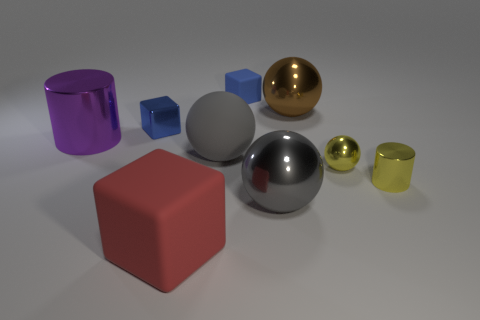How big is the object that is both in front of the blue shiny cube and on the left side of the big red matte object?
Ensure brevity in your answer.  Large. Is there a small object that has the same color as the small sphere?
Keep it short and to the point. Yes. There is a cylinder on the left side of the small blue cube on the left side of the red cube; what is its color?
Your answer should be very brief. Purple. Are there fewer tiny yellow cylinders in front of the big red cube than tiny blue blocks on the left side of the tiny blue metallic object?
Offer a very short reply. No. Do the red matte object and the yellow shiny cylinder have the same size?
Make the answer very short. No. There is a large thing that is behind the rubber sphere and right of the big cylinder; what is its shape?
Provide a succinct answer. Sphere. How many small spheres are made of the same material as the brown object?
Provide a short and direct response. 1. There is a big shiny object behind the big purple shiny cylinder; how many large red cubes are on the right side of it?
Your answer should be very brief. 0. There is a large gray object behind the big metallic ball that is in front of the cylinder that is to the right of the blue rubber cube; what shape is it?
Provide a short and direct response. Sphere. What is the size of the metal ball that is the same color as the tiny cylinder?
Offer a terse response. Small. 